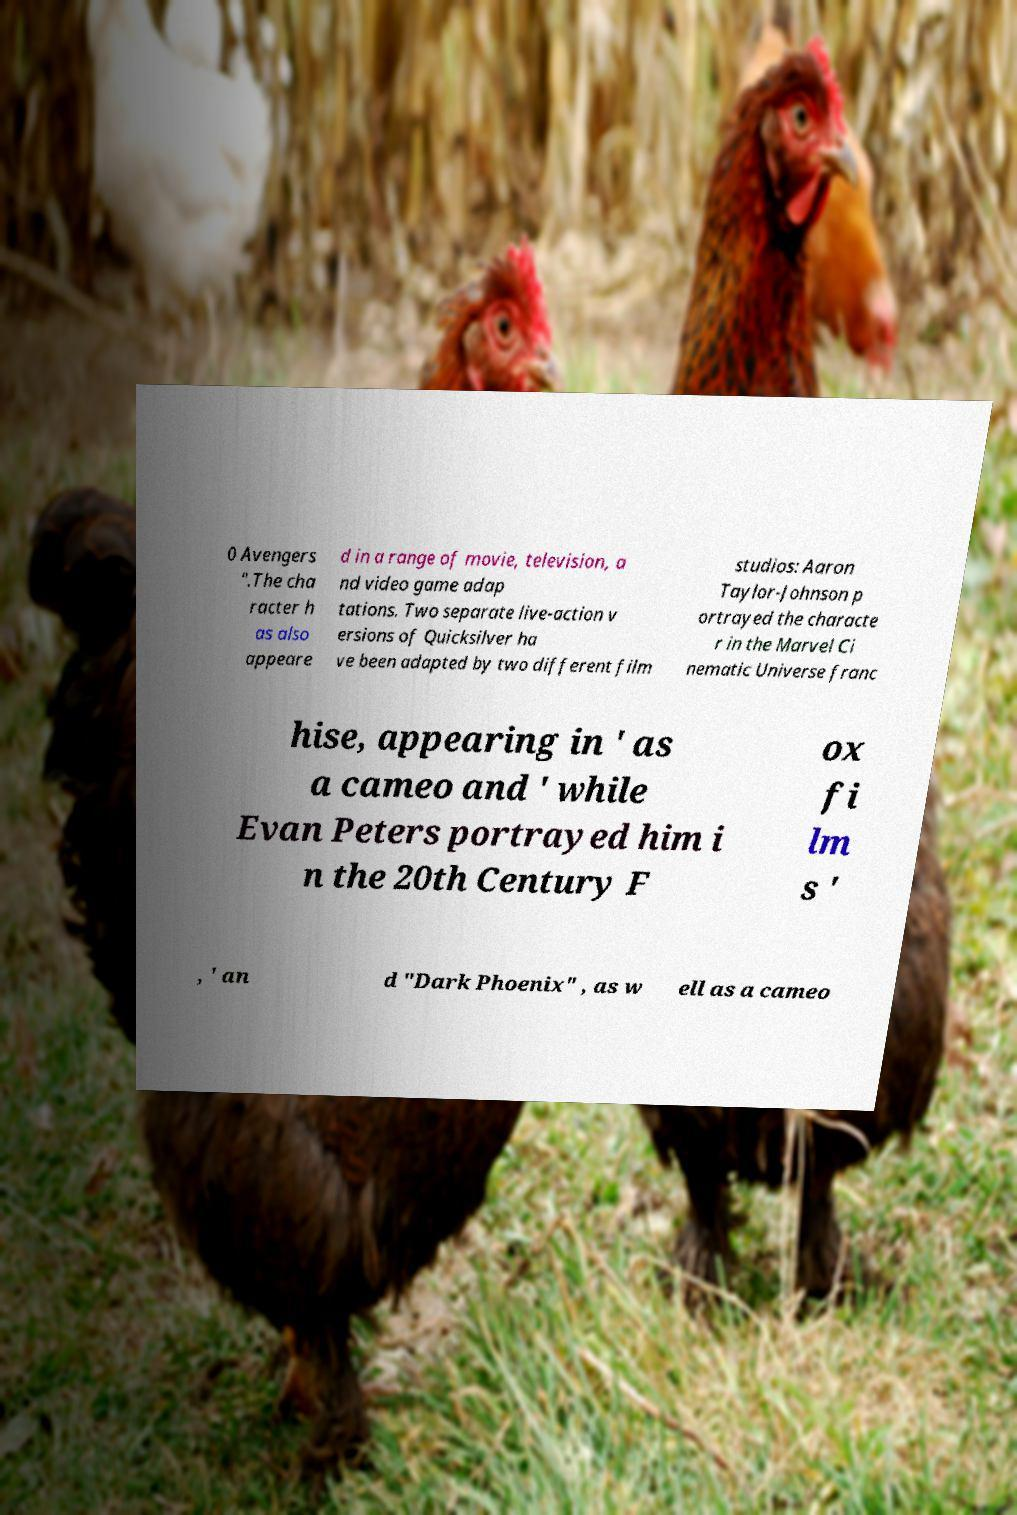There's text embedded in this image that I need extracted. Can you transcribe it verbatim? 0 Avengers ".The cha racter h as also appeare d in a range of movie, television, a nd video game adap tations. Two separate live-action v ersions of Quicksilver ha ve been adapted by two different film studios: Aaron Taylor-Johnson p ortrayed the characte r in the Marvel Ci nematic Universe franc hise, appearing in ' as a cameo and ' while Evan Peters portrayed him i n the 20th Century F ox fi lm s ' , ' an d "Dark Phoenix" , as w ell as a cameo 